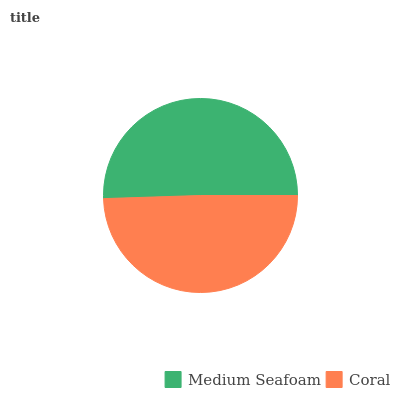Is Coral the minimum?
Answer yes or no. Yes. Is Medium Seafoam the maximum?
Answer yes or no. Yes. Is Coral the maximum?
Answer yes or no. No. Is Medium Seafoam greater than Coral?
Answer yes or no. Yes. Is Coral less than Medium Seafoam?
Answer yes or no. Yes. Is Coral greater than Medium Seafoam?
Answer yes or no. No. Is Medium Seafoam less than Coral?
Answer yes or no. No. Is Medium Seafoam the high median?
Answer yes or no. Yes. Is Coral the low median?
Answer yes or no. Yes. Is Coral the high median?
Answer yes or no. No. Is Medium Seafoam the low median?
Answer yes or no. No. 